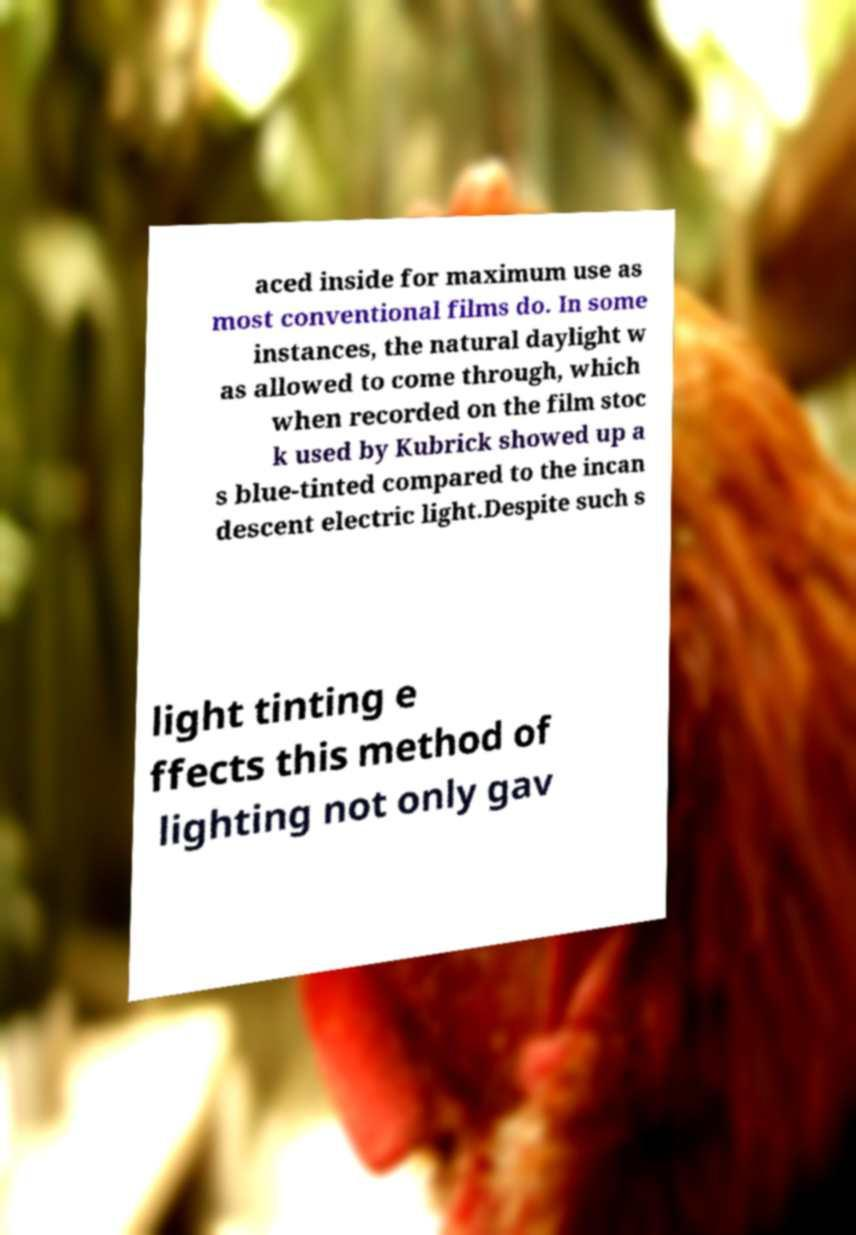Could you extract and type out the text from this image? aced inside for maximum use as most conventional films do. In some instances, the natural daylight w as allowed to come through, which when recorded on the film stoc k used by Kubrick showed up a s blue-tinted compared to the incan descent electric light.Despite such s light tinting e ffects this method of lighting not only gav 